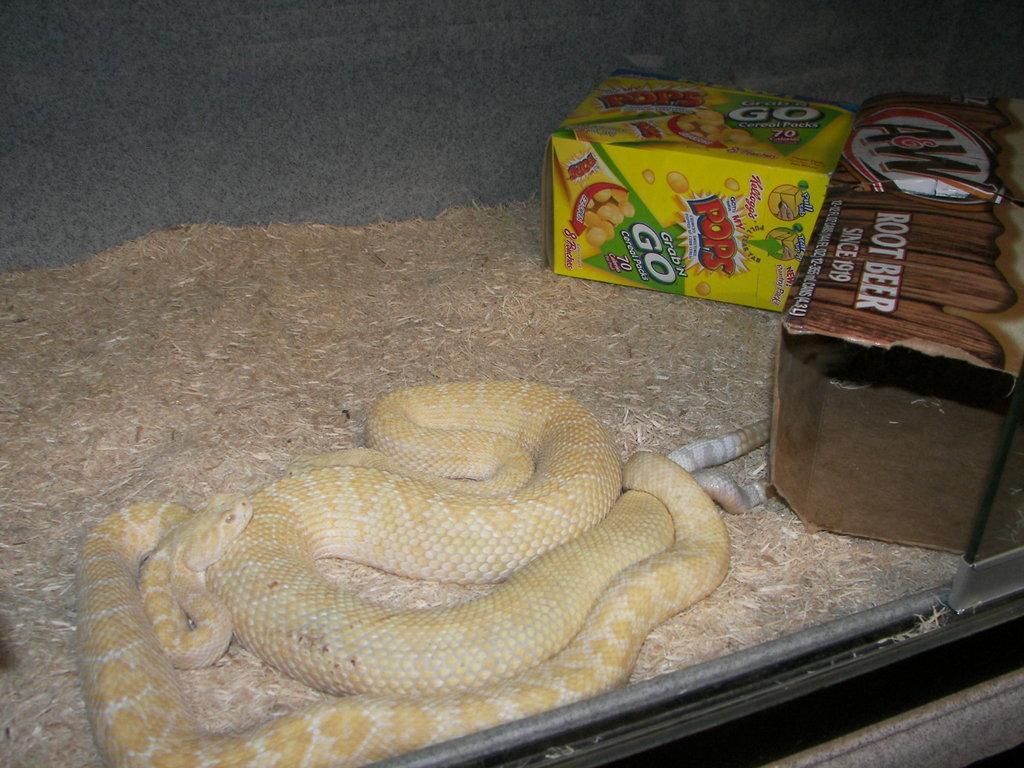In one or two sentences, can you explain what this image depicts? In this image in the front there is a snake and there are boxes with some text and images on it and there is dry grass. 